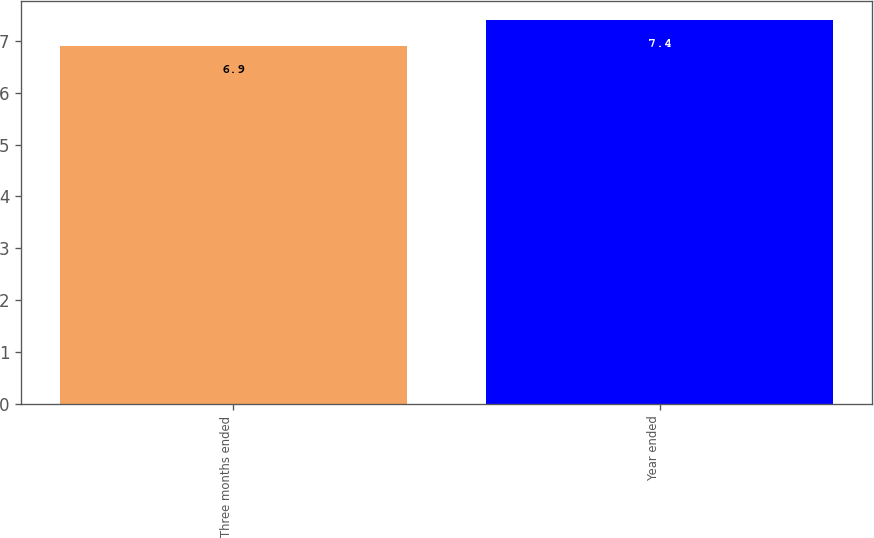Convert chart to OTSL. <chart><loc_0><loc_0><loc_500><loc_500><bar_chart><fcel>Three months ended<fcel>Year ended<nl><fcel>6.9<fcel>7.4<nl></chart> 